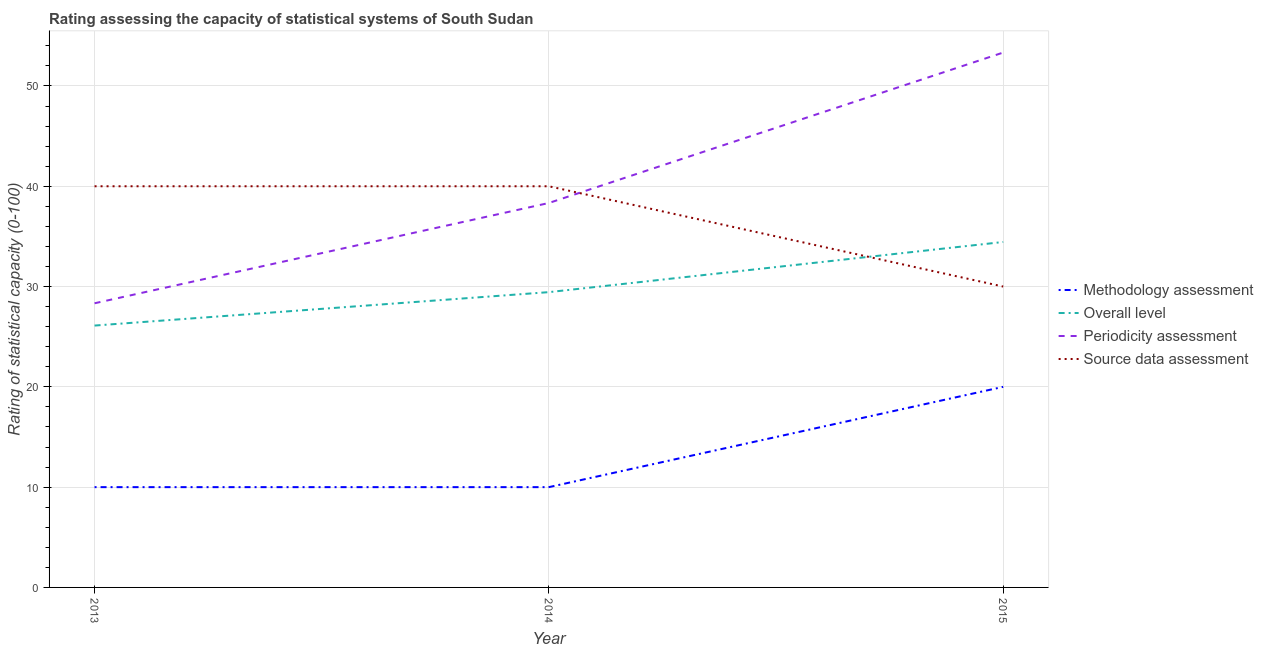What is the source data assessment rating in 2013?
Offer a very short reply. 40. Across all years, what is the maximum periodicity assessment rating?
Offer a very short reply. 53.33. Across all years, what is the minimum overall level rating?
Offer a very short reply. 26.11. What is the total methodology assessment rating in the graph?
Your answer should be compact. 40. What is the difference between the source data assessment rating in 2013 and that in 2015?
Offer a very short reply. 10. What is the difference between the periodicity assessment rating in 2015 and the methodology assessment rating in 2014?
Keep it short and to the point. 43.33. What is the average periodicity assessment rating per year?
Give a very brief answer. 40. In the year 2015, what is the difference between the source data assessment rating and overall level rating?
Keep it short and to the point. -4.44. What is the ratio of the overall level rating in 2013 to that in 2015?
Ensure brevity in your answer.  0.76. What is the difference between the highest and the second highest methodology assessment rating?
Your answer should be very brief. 10. What is the difference between the highest and the lowest source data assessment rating?
Offer a very short reply. 10. Is the sum of the methodology assessment rating in 2014 and 2015 greater than the maximum source data assessment rating across all years?
Ensure brevity in your answer.  No. Does the periodicity assessment rating monotonically increase over the years?
Provide a succinct answer. Yes. Is the source data assessment rating strictly greater than the periodicity assessment rating over the years?
Provide a succinct answer. No. How many lines are there?
Offer a terse response. 4. What is the difference between two consecutive major ticks on the Y-axis?
Your answer should be compact. 10. Does the graph contain grids?
Offer a very short reply. Yes. Where does the legend appear in the graph?
Ensure brevity in your answer.  Center right. How many legend labels are there?
Your answer should be compact. 4. What is the title of the graph?
Make the answer very short. Rating assessing the capacity of statistical systems of South Sudan. What is the label or title of the Y-axis?
Provide a short and direct response. Rating of statistical capacity (0-100). What is the Rating of statistical capacity (0-100) of Methodology assessment in 2013?
Ensure brevity in your answer.  10. What is the Rating of statistical capacity (0-100) in Overall level in 2013?
Provide a succinct answer. 26.11. What is the Rating of statistical capacity (0-100) of Periodicity assessment in 2013?
Your response must be concise. 28.33. What is the Rating of statistical capacity (0-100) in Overall level in 2014?
Ensure brevity in your answer.  29.44. What is the Rating of statistical capacity (0-100) of Periodicity assessment in 2014?
Your response must be concise. 38.33. What is the Rating of statistical capacity (0-100) in Source data assessment in 2014?
Give a very brief answer. 40. What is the Rating of statistical capacity (0-100) in Overall level in 2015?
Offer a terse response. 34.44. What is the Rating of statistical capacity (0-100) in Periodicity assessment in 2015?
Give a very brief answer. 53.33. Across all years, what is the maximum Rating of statistical capacity (0-100) of Methodology assessment?
Provide a succinct answer. 20. Across all years, what is the maximum Rating of statistical capacity (0-100) in Overall level?
Provide a succinct answer. 34.44. Across all years, what is the maximum Rating of statistical capacity (0-100) in Periodicity assessment?
Your answer should be compact. 53.33. Across all years, what is the maximum Rating of statistical capacity (0-100) in Source data assessment?
Make the answer very short. 40. Across all years, what is the minimum Rating of statistical capacity (0-100) of Overall level?
Keep it short and to the point. 26.11. Across all years, what is the minimum Rating of statistical capacity (0-100) of Periodicity assessment?
Your answer should be very brief. 28.33. What is the total Rating of statistical capacity (0-100) in Methodology assessment in the graph?
Your response must be concise. 40. What is the total Rating of statistical capacity (0-100) of Overall level in the graph?
Keep it short and to the point. 90. What is the total Rating of statistical capacity (0-100) in Periodicity assessment in the graph?
Offer a terse response. 120. What is the total Rating of statistical capacity (0-100) of Source data assessment in the graph?
Make the answer very short. 110. What is the difference between the Rating of statistical capacity (0-100) in Methodology assessment in 2013 and that in 2015?
Provide a succinct answer. -10. What is the difference between the Rating of statistical capacity (0-100) in Overall level in 2013 and that in 2015?
Provide a short and direct response. -8.33. What is the difference between the Rating of statistical capacity (0-100) in Periodicity assessment in 2013 and that in 2015?
Offer a terse response. -25. What is the difference between the Rating of statistical capacity (0-100) in Overall level in 2014 and that in 2015?
Your answer should be compact. -5. What is the difference between the Rating of statistical capacity (0-100) of Periodicity assessment in 2014 and that in 2015?
Provide a succinct answer. -15. What is the difference between the Rating of statistical capacity (0-100) of Source data assessment in 2014 and that in 2015?
Your response must be concise. 10. What is the difference between the Rating of statistical capacity (0-100) of Methodology assessment in 2013 and the Rating of statistical capacity (0-100) of Overall level in 2014?
Keep it short and to the point. -19.44. What is the difference between the Rating of statistical capacity (0-100) in Methodology assessment in 2013 and the Rating of statistical capacity (0-100) in Periodicity assessment in 2014?
Provide a short and direct response. -28.33. What is the difference between the Rating of statistical capacity (0-100) in Overall level in 2013 and the Rating of statistical capacity (0-100) in Periodicity assessment in 2014?
Make the answer very short. -12.22. What is the difference between the Rating of statistical capacity (0-100) in Overall level in 2013 and the Rating of statistical capacity (0-100) in Source data assessment in 2014?
Your answer should be compact. -13.89. What is the difference between the Rating of statistical capacity (0-100) of Periodicity assessment in 2013 and the Rating of statistical capacity (0-100) of Source data assessment in 2014?
Your response must be concise. -11.67. What is the difference between the Rating of statistical capacity (0-100) in Methodology assessment in 2013 and the Rating of statistical capacity (0-100) in Overall level in 2015?
Make the answer very short. -24.44. What is the difference between the Rating of statistical capacity (0-100) in Methodology assessment in 2013 and the Rating of statistical capacity (0-100) in Periodicity assessment in 2015?
Provide a succinct answer. -43.33. What is the difference between the Rating of statistical capacity (0-100) in Overall level in 2013 and the Rating of statistical capacity (0-100) in Periodicity assessment in 2015?
Your response must be concise. -27.22. What is the difference between the Rating of statistical capacity (0-100) in Overall level in 2013 and the Rating of statistical capacity (0-100) in Source data assessment in 2015?
Provide a succinct answer. -3.89. What is the difference between the Rating of statistical capacity (0-100) in Periodicity assessment in 2013 and the Rating of statistical capacity (0-100) in Source data assessment in 2015?
Your answer should be compact. -1.67. What is the difference between the Rating of statistical capacity (0-100) of Methodology assessment in 2014 and the Rating of statistical capacity (0-100) of Overall level in 2015?
Provide a short and direct response. -24.44. What is the difference between the Rating of statistical capacity (0-100) of Methodology assessment in 2014 and the Rating of statistical capacity (0-100) of Periodicity assessment in 2015?
Your answer should be very brief. -43.33. What is the difference between the Rating of statistical capacity (0-100) in Overall level in 2014 and the Rating of statistical capacity (0-100) in Periodicity assessment in 2015?
Your answer should be very brief. -23.89. What is the difference between the Rating of statistical capacity (0-100) in Overall level in 2014 and the Rating of statistical capacity (0-100) in Source data assessment in 2015?
Your response must be concise. -0.56. What is the difference between the Rating of statistical capacity (0-100) in Periodicity assessment in 2014 and the Rating of statistical capacity (0-100) in Source data assessment in 2015?
Your response must be concise. 8.33. What is the average Rating of statistical capacity (0-100) in Methodology assessment per year?
Provide a succinct answer. 13.33. What is the average Rating of statistical capacity (0-100) in Periodicity assessment per year?
Provide a short and direct response. 40. What is the average Rating of statistical capacity (0-100) of Source data assessment per year?
Make the answer very short. 36.67. In the year 2013, what is the difference between the Rating of statistical capacity (0-100) in Methodology assessment and Rating of statistical capacity (0-100) in Overall level?
Offer a very short reply. -16.11. In the year 2013, what is the difference between the Rating of statistical capacity (0-100) in Methodology assessment and Rating of statistical capacity (0-100) in Periodicity assessment?
Your answer should be compact. -18.33. In the year 2013, what is the difference between the Rating of statistical capacity (0-100) in Methodology assessment and Rating of statistical capacity (0-100) in Source data assessment?
Your answer should be very brief. -30. In the year 2013, what is the difference between the Rating of statistical capacity (0-100) in Overall level and Rating of statistical capacity (0-100) in Periodicity assessment?
Make the answer very short. -2.22. In the year 2013, what is the difference between the Rating of statistical capacity (0-100) in Overall level and Rating of statistical capacity (0-100) in Source data assessment?
Offer a terse response. -13.89. In the year 2013, what is the difference between the Rating of statistical capacity (0-100) in Periodicity assessment and Rating of statistical capacity (0-100) in Source data assessment?
Give a very brief answer. -11.67. In the year 2014, what is the difference between the Rating of statistical capacity (0-100) in Methodology assessment and Rating of statistical capacity (0-100) in Overall level?
Ensure brevity in your answer.  -19.44. In the year 2014, what is the difference between the Rating of statistical capacity (0-100) of Methodology assessment and Rating of statistical capacity (0-100) of Periodicity assessment?
Provide a short and direct response. -28.33. In the year 2014, what is the difference between the Rating of statistical capacity (0-100) of Methodology assessment and Rating of statistical capacity (0-100) of Source data assessment?
Give a very brief answer. -30. In the year 2014, what is the difference between the Rating of statistical capacity (0-100) of Overall level and Rating of statistical capacity (0-100) of Periodicity assessment?
Keep it short and to the point. -8.89. In the year 2014, what is the difference between the Rating of statistical capacity (0-100) in Overall level and Rating of statistical capacity (0-100) in Source data assessment?
Give a very brief answer. -10.56. In the year 2014, what is the difference between the Rating of statistical capacity (0-100) in Periodicity assessment and Rating of statistical capacity (0-100) in Source data assessment?
Keep it short and to the point. -1.67. In the year 2015, what is the difference between the Rating of statistical capacity (0-100) in Methodology assessment and Rating of statistical capacity (0-100) in Overall level?
Your response must be concise. -14.44. In the year 2015, what is the difference between the Rating of statistical capacity (0-100) in Methodology assessment and Rating of statistical capacity (0-100) in Periodicity assessment?
Provide a short and direct response. -33.33. In the year 2015, what is the difference between the Rating of statistical capacity (0-100) in Methodology assessment and Rating of statistical capacity (0-100) in Source data assessment?
Keep it short and to the point. -10. In the year 2015, what is the difference between the Rating of statistical capacity (0-100) in Overall level and Rating of statistical capacity (0-100) in Periodicity assessment?
Provide a succinct answer. -18.89. In the year 2015, what is the difference between the Rating of statistical capacity (0-100) in Overall level and Rating of statistical capacity (0-100) in Source data assessment?
Provide a short and direct response. 4.44. In the year 2015, what is the difference between the Rating of statistical capacity (0-100) of Periodicity assessment and Rating of statistical capacity (0-100) of Source data assessment?
Make the answer very short. 23.33. What is the ratio of the Rating of statistical capacity (0-100) in Overall level in 2013 to that in 2014?
Provide a short and direct response. 0.89. What is the ratio of the Rating of statistical capacity (0-100) of Periodicity assessment in 2013 to that in 2014?
Keep it short and to the point. 0.74. What is the ratio of the Rating of statistical capacity (0-100) of Source data assessment in 2013 to that in 2014?
Your answer should be compact. 1. What is the ratio of the Rating of statistical capacity (0-100) in Methodology assessment in 2013 to that in 2015?
Offer a terse response. 0.5. What is the ratio of the Rating of statistical capacity (0-100) of Overall level in 2013 to that in 2015?
Provide a short and direct response. 0.76. What is the ratio of the Rating of statistical capacity (0-100) in Periodicity assessment in 2013 to that in 2015?
Keep it short and to the point. 0.53. What is the ratio of the Rating of statistical capacity (0-100) of Overall level in 2014 to that in 2015?
Offer a very short reply. 0.85. What is the ratio of the Rating of statistical capacity (0-100) in Periodicity assessment in 2014 to that in 2015?
Ensure brevity in your answer.  0.72. What is the difference between the highest and the second highest Rating of statistical capacity (0-100) of Methodology assessment?
Your answer should be very brief. 10. What is the difference between the highest and the second highest Rating of statistical capacity (0-100) in Overall level?
Your answer should be compact. 5. What is the difference between the highest and the second highest Rating of statistical capacity (0-100) of Periodicity assessment?
Offer a terse response. 15. What is the difference between the highest and the second highest Rating of statistical capacity (0-100) of Source data assessment?
Keep it short and to the point. 0. What is the difference between the highest and the lowest Rating of statistical capacity (0-100) of Methodology assessment?
Offer a terse response. 10. What is the difference between the highest and the lowest Rating of statistical capacity (0-100) in Overall level?
Keep it short and to the point. 8.33. What is the difference between the highest and the lowest Rating of statistical capacity (0-100) in Periodicity assessment?
Your answer should be very brief. 25. 